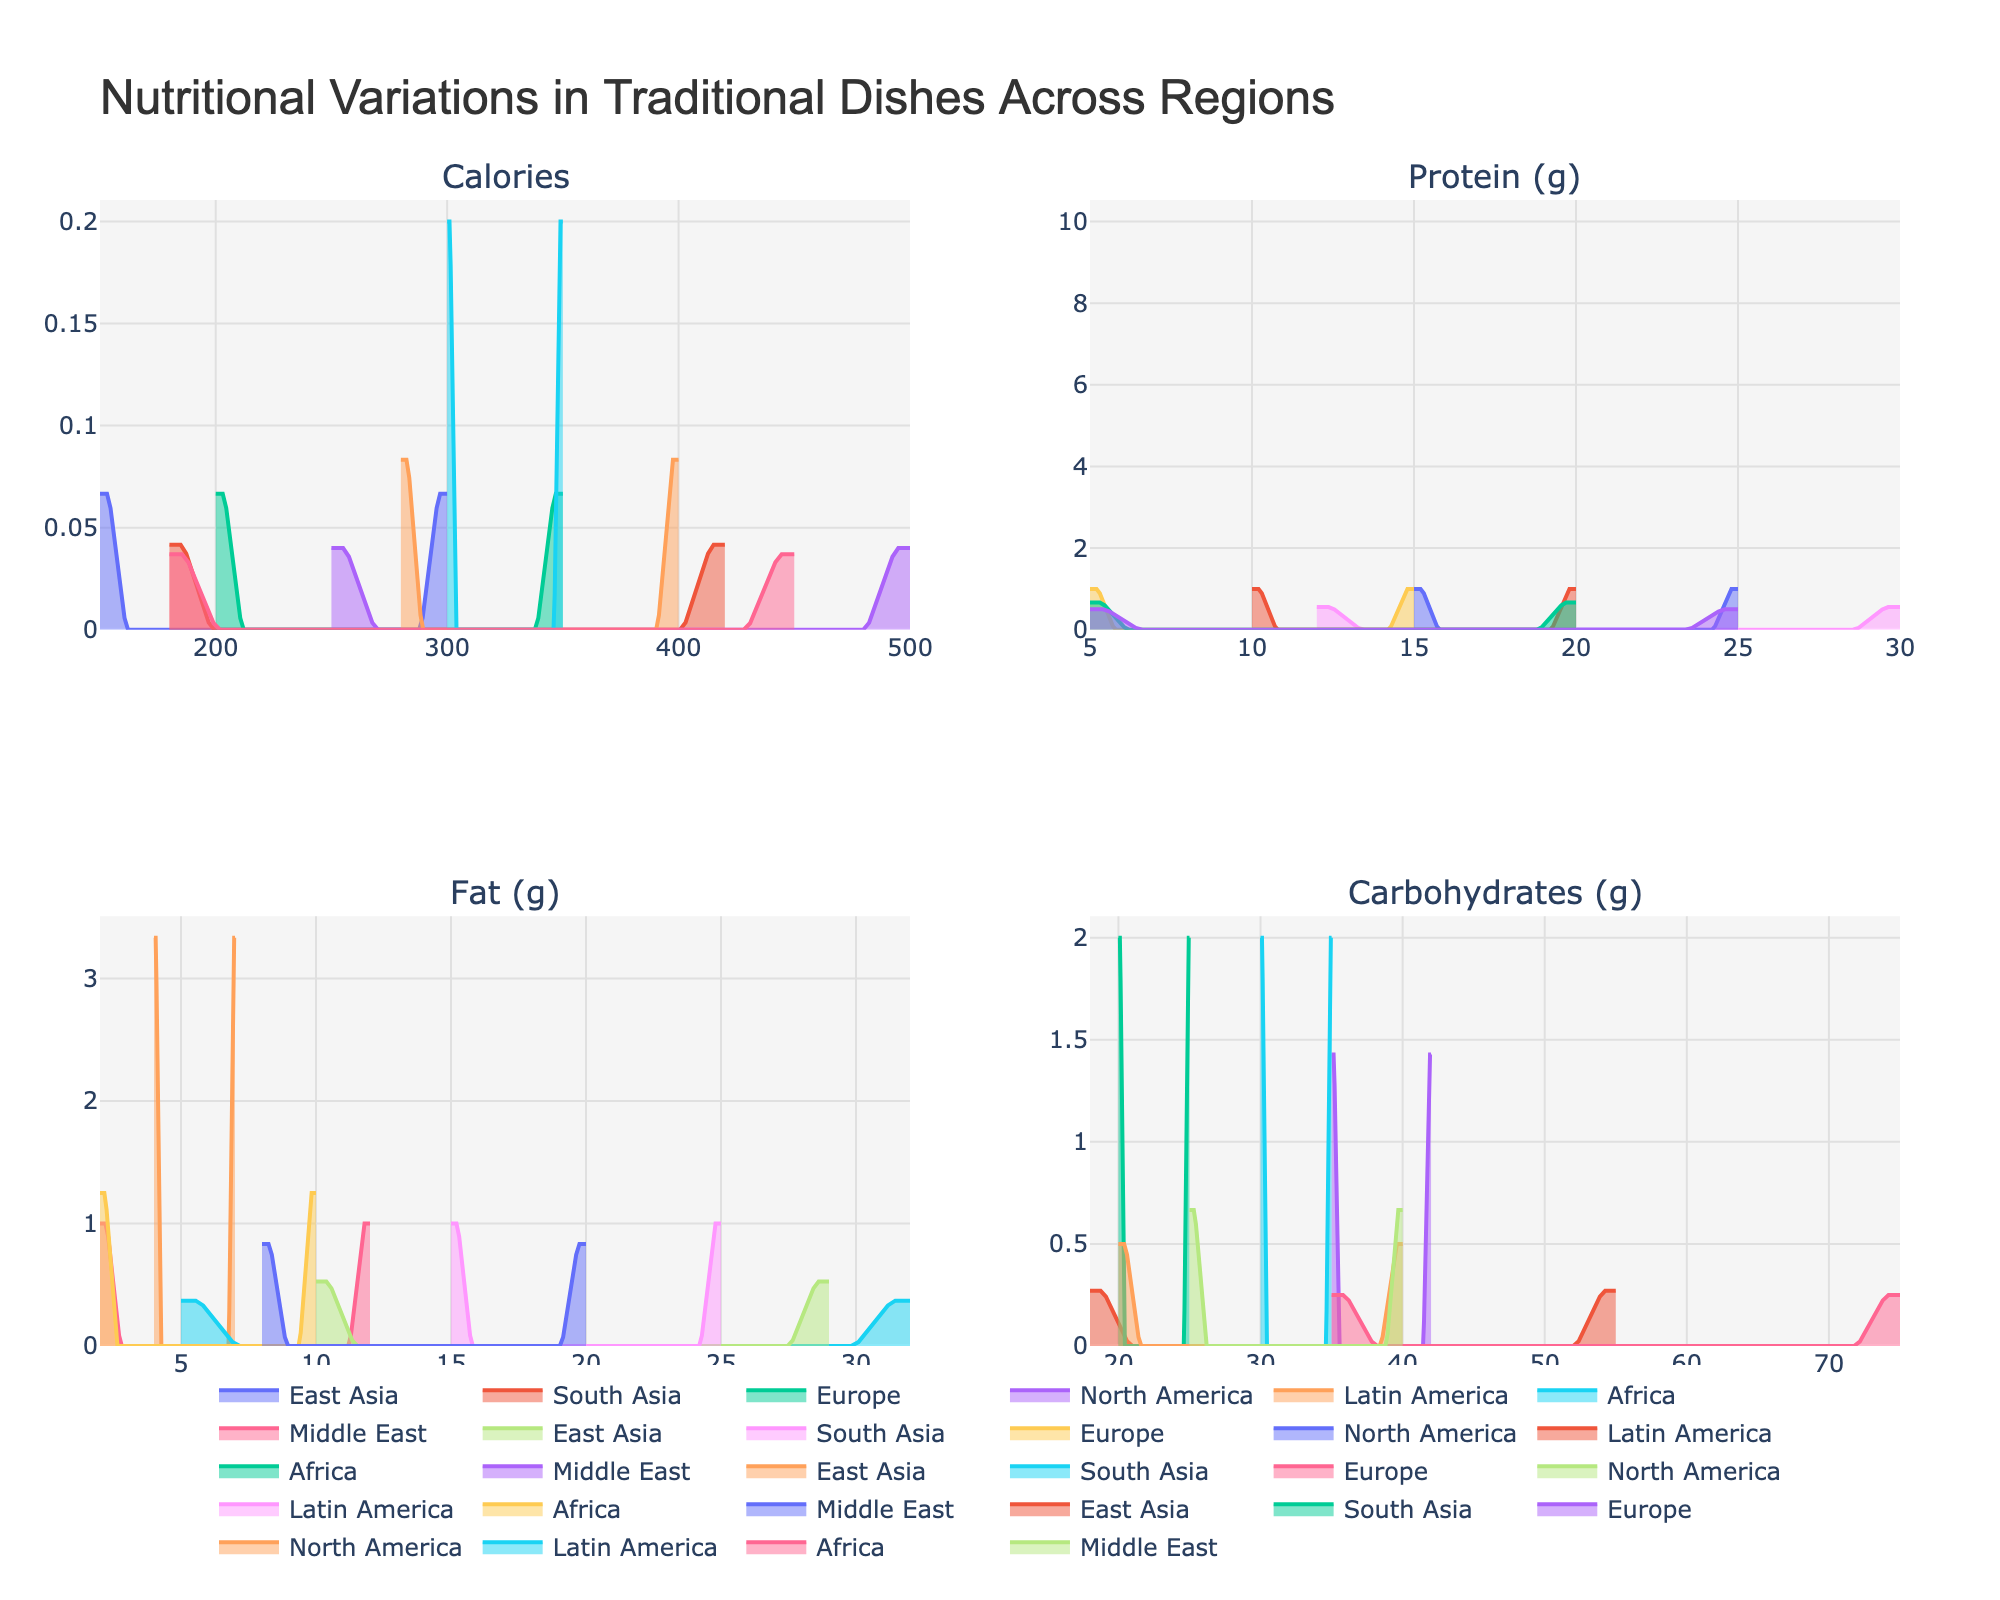what is the title of this figure? The title of the figure is usually at the top of the plot and is clearly visible. In this case, it reads 'Nutritional Variations in Traditional Dishes Across Regions'.
Answer: Nutritional Variations in Traditional Dishes Across Regions How many regions are compared in each subplot? Each subplot, which represents a different nutrient (Calories, Protein (g), Fat (g), Carbohydrates (g)), has the same number of regions. By counting unique regions listed in the data ('East Asia', 'South Asia', 'Europe', 'North America', 'Latin America', 'Africa', 'Middle East'), we see there are seven.
Answer: 7 Which region has the highest density peak for calories? Examining the subplot for 'Calories', we compare the peak densities for each region. The region with the highest peak density will be the one whose curve reaches the highest point.
Answer: North America For which nutrient do the Middle Eastern dishes show the widest density curve? In each subplot, we look at the width of the Middle Eastern curve to see which nutrient has the widest spread from left to right. The curve that spans the most range will indicate the widest density.
Answer: Carbohydrates Are traditional dishes from South Asia higher in fats or proteins? By comparing the heights and spans of the density curves for 'Fat (g)' and 'Protein (g)' in the respective subplots, we can observe which nutrient South Asian dishes have more prominently. The curve that rises higher or sustains density over a broader range indicates a higher content.
Answer: Protein (g) Which nutrient shows the least variation across all regions? The nutrient with the least variation will have the narrowest and most consistent density curves across all regions in its subplot.
Answer: Carbohydrates (g) How do Latin American dishes compare to African dishes in terms of protein (g)? By looking at the 'Protein (g)' subplot, compare the height and distribution of curves for Latin American and African regions. The curve that is generally higher indicates a higher average protein content.
Answer: Africa Which region has the most diverse range of calories in its traditional dishes? The region with the most diverse range will have the widest spread in its density curve for the 'Calories' subplot. This means the curve stretches over a larger range of values on the x-axis.
Answer: North America Is there a region whose traditional dishes are balanced across all nutrients? A balanced region would have density curves for all nutrients that are similarly distributed and don't show extreme peaks or variations. Examining each subplot for consistency in the distribution of a region's curves will identify this.
Answer: No specific region is perfectly balanced, but Europe indicates relative consistency Which nutrient seems to dominate in traditional North American dishes? By observing all subplots, identify which nutrient has the tallest and widest density curve for North America, indicating a higher typical content in the dishes.
Answer: Calories 